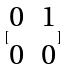<formula> <loc_0><loc_0><loc_500><loc_500>[ \begin{matrix} 0 & 1 \\ 0 & 0 \end{matrix} ]</formula> 